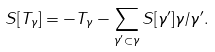<formula> <loc_0><loc_0><loc_500><loc_500>S [ T _ { \gamma } ] = - T _ { \gamma } - \sum _ { \gamma ^ { \prime } \subset \gamma } S [ \gamma ^ { \prime } ] \gamma / \gamma ^ { \prime } .</formula> 